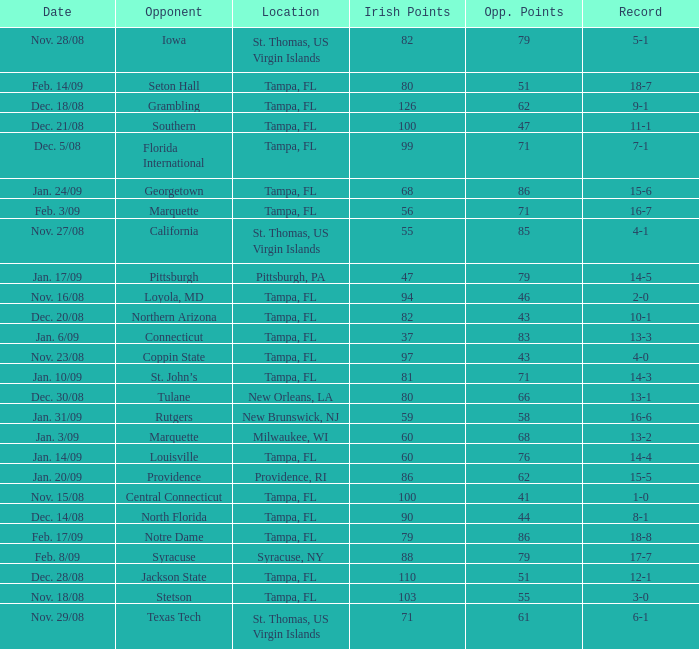What is the record where the opponent is central connecticut? 1-0. 